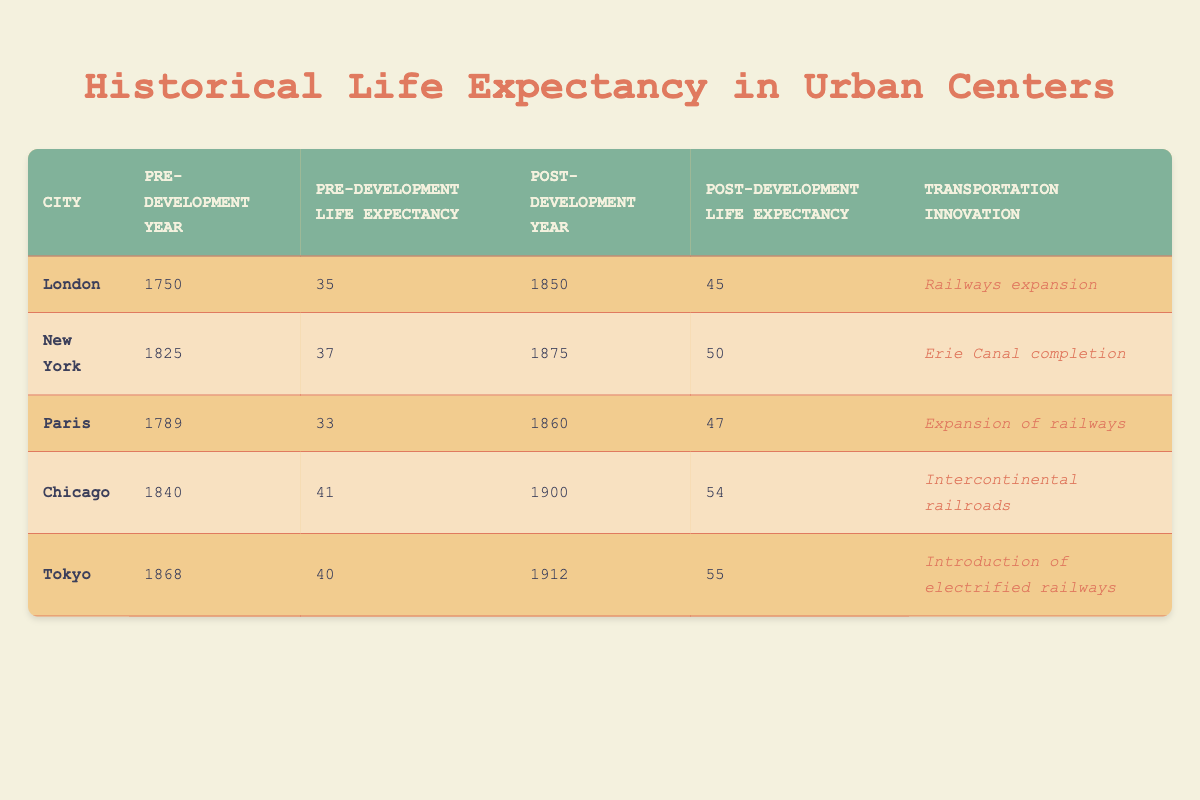What was the life expectancy in London before the transportation development? The table indicates that the pre-transportation development life expectancy in London was 35 years in the year 1750.
Answer: 35 How much did life expectancy increase in New York after the Erie Canal completion? To find the increase, subtract the pre-development life expectancy (37 in 1825) from the post-development life expectancy (50 in 1875): 50 - 37 = 13.
Answer: 13 Was the life expectancy in Paris greater before or after the expansion of railways? Before the transportation development (33 in 1789) was less than after the expansion of railways (47 in 1860), indicating that life expectancy was greater post-development.
Answer: Yes Which city had the highest life expectancy post-transportation development, and what was that value? The table shows that Chicago had the highest post-development life expectancy at 54 years in 1900, compared to other cities.
Answer: Chicago, 54 What is the average life expectancy increase across all cities after their respective transportation developments? First, calculate the total life expectancy increases: London (10), New York (13), Paris (14), Chicago (13), and Tokyo (15) gives a total of 65. There are 5 cities, so the average increase is 65/5 = 13.
Answer: 13 